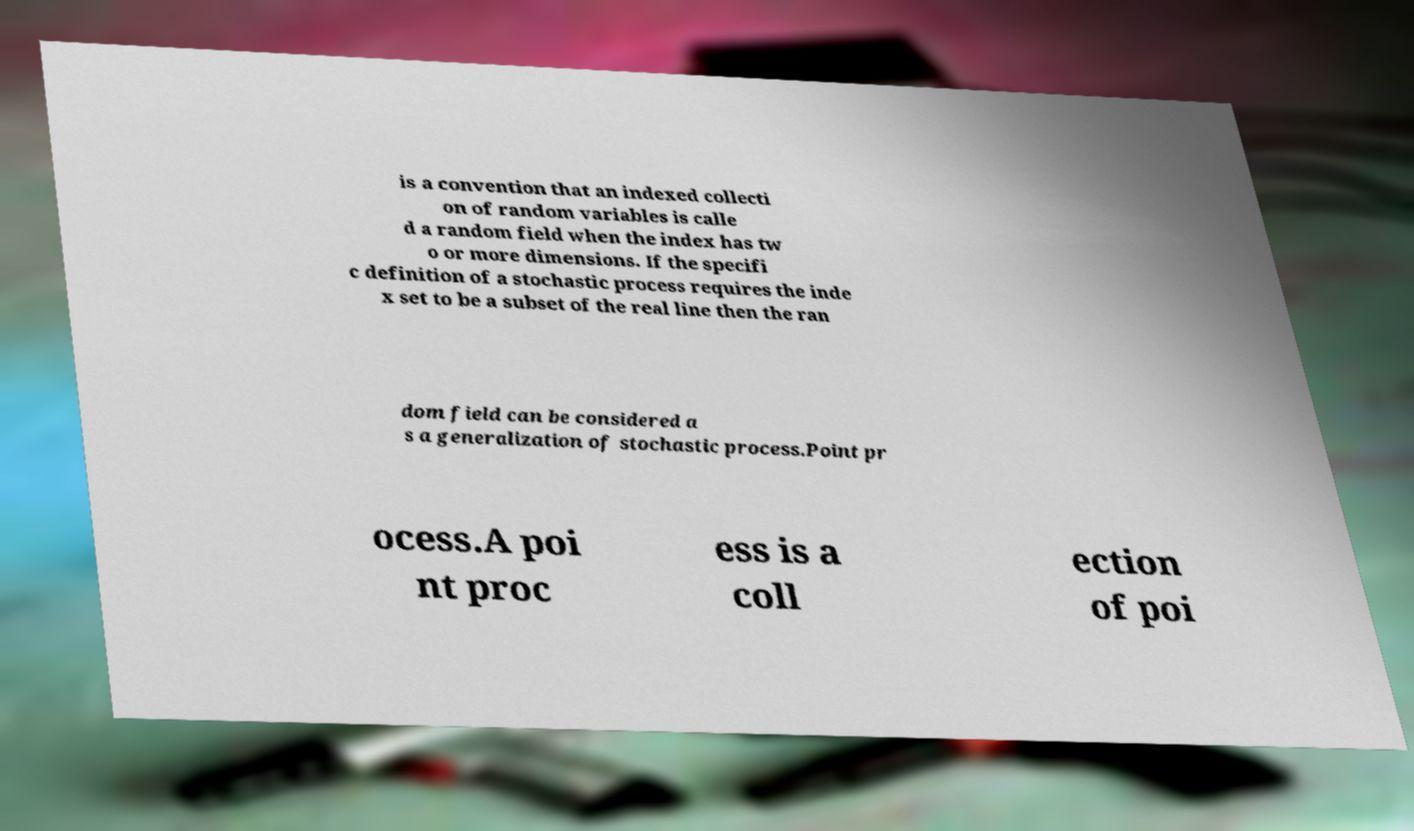Could you extract and type out the text from this image? is a convention that an indexed collecti on of random variables is calle d a random field when the index has tw o or more dimensions. If the specifi c definition of a stochastic process requires the inde x set to be a subset of the real line then the ran dom field can be considered a s a generalization of stochastic process.Point pr ocess.A poi nt proc ess is a coll ection of poi 